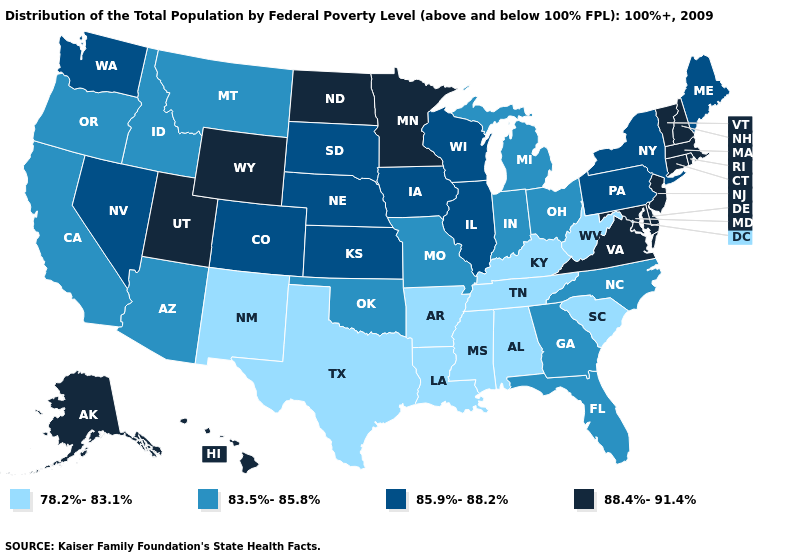Which states have the highest value in the USA?
Give a very brief answer. Alaska, Connecticut, Delaware, Hawaii, Maryland, Massachusetts, Minnesota, New Hampshire, New Jersey, North Dakota, Rhode Island, Utah, Vermont, Virginia, Wyoming. Does Arkansas have the lowest value in the South?
Short answer required. Yes. Does New York have a lower value than Illinois?
Keep it brief. No. Which states have the highest value in the USA?
Concise answer only. Alaska, Connecticut, Delaware, Hawaii, Maryland, Massachusetts, Minnesota, New Hampshire, New Jersey, North Dakota, Rhode Island, Utah, Vermont, Virginia, Wyoming. Name the states that have a value in the range 83.5%-85.8%?
Write a very short answer. Arizona, California, Florida, Georgia, Idaho, Indiana, Michigan, Missouri, Montana, North Carolina, Ohio, Oklahoma, Oregon. What is the lowest value in the USA?
Keep it brief. 78.2%-83.1%. What is the lowest value in the USA?
Be succinct. 78.2%-83.1%. Name the states that have a value in the range 85.9%-88.2%?
Keep it brief. Colorado, Illinois, Iowa, Kansas, Maine, Nebraska, Nevada, New York, Pennsylvania, South Dakota, Washington, Wisconsin. Does Virginia have the highest value in the South?
Concise answer only. Yes. Name the states that have a value in the range 88.4%-91.4%?
Concise answer only. Alaska, Connecticut, Delaware, Hawaii, Maryland, Massachusetts, Minnesota, New Hampshire, New Jersey, North Dakota, Rhode Island, Utah, Vermont, Virginia, Wyoming. Does the first symbol in the legend represent the smallest category?
Give a very brief answer. Yes. Does Massachusetts have the highest value in the USA?
Keep it brief. Yes. Does Hawaii have the highest value in the West?
Be succinct. Yes. Among the states that border Illinois , which have the highest value?
Quick response, please. Iowa, Wisconsin. Name the states that have a value in the range 83.5%-85.8%?
Short answer required. Arizona, California, Florida, Georgia, Idaho, Indiana, Michigan, Missouri, Montana, North Carolina, Ohio, Oklahoma, Oregon. 